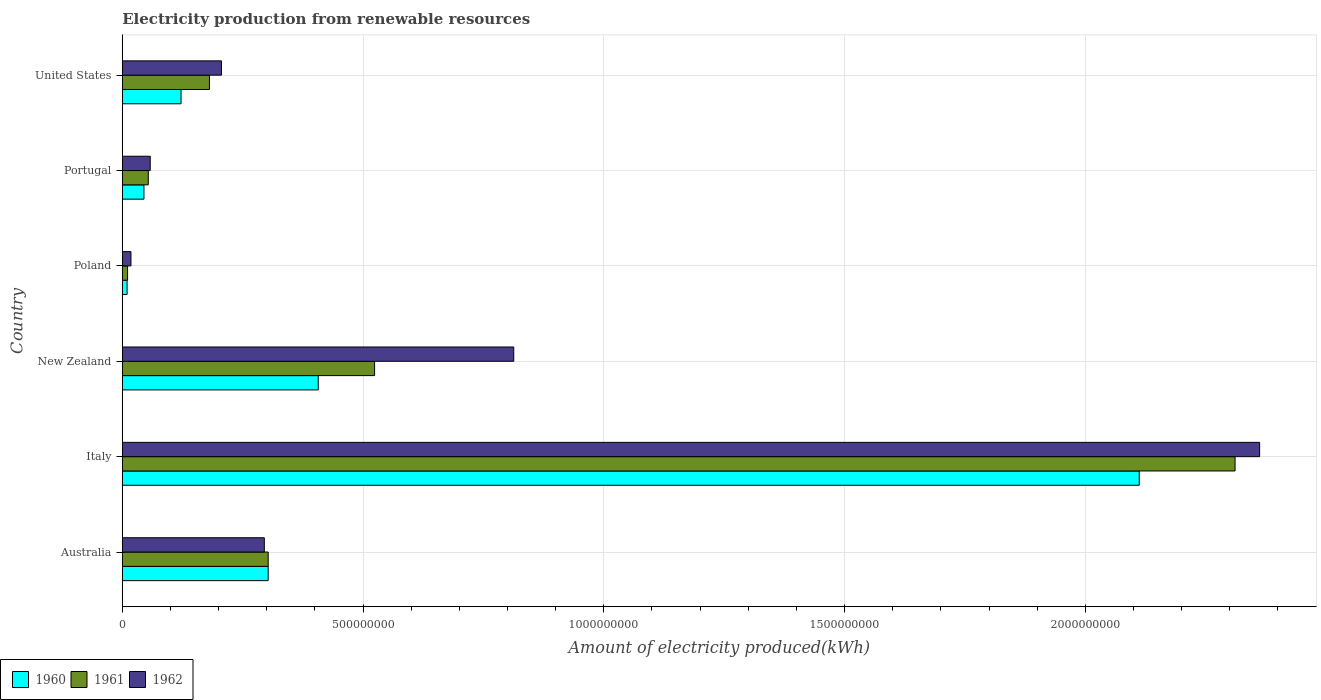Are the number of bars per tick equal to the number of legend labels?
Ensure brevity in your answer.  Yes. Are the number of bars on each tick of the Y-axis equal?
Offer a very short reply. Yes. How many bars are there on the 3rd tick from the bottom?
Provide a succinct answer. 3. Across all countries, what is the maximum amount of electricity produced in 1961?
Give a very brief answer. 2.31e+09. Across all countries, what is the minimum amount of electricity produced in 1961?
Offer a very short reply. 1.10e+07. What is the total amount of electricity produced in 1962 in the graph?
Provide a succinct answer. 3.75e+09. What is the difference between the amount of electricity produced in 1960 in New Zealand and that in Portugal?
Provide a short and direct response. 3.62e+08. What is the difference between the amount of electricity produced in 1962 in United States and the amount of electricity produced in 1960 in Portugal?
Keep it short and to the point. 1.61e+08. What is the average amount of electricity produced in 1962 per country?
Your answer should be compact. 6.25e+08. What is the difference between the amount of electricity produced in 1960 and amount of electricity produced in 1961 in Portugal?
Offer a terse response. -9.00e+06. In how many countries, is the amount of electricity produced in 1960 greater than 400000000 kWh?
Ensure brevity in your answer.  2. What is the ratio of the amount of electricity produced in 1962 in Italy to that in New Zealand?
Offer a very short reply. 2.91. Is the difference between the amount of electricity produced in 1960 in Australia and New Zealand greater than the difference between the amount of electricity produced in 1961 in Australia and New Zealand?
Offer a terse response. Yes. What is the difference between the highest and the second highest amount of electricity produced in 1961?
Give a very brief answer. 1.79e+09. What is the difference between the highest and the lowest amount of electricity produced in 1962?
Provide a succinct answer. 2.34e+09. What does the 3rd bar from the top in Portugal represents?
Provide a succinct answer. 1960. Are the values on the major ticks of X-axis written in scientific E-notation?
Provide a short and direct response. No. Does the graph contain any zero values?
Give a very brief answer. No. Where does the legend appear in the graph?
Your response must be concise. Bottom left. How many legend labels are there?
Your response must be concise. 3. What is the title of the graph?
Keep it short and to the point. Electricity production from renewable resources. Does "2001" appear as one of the legend labels in the graph?
Offer a very short reply. No. What is the label or title of the X-axis?
Ensure brevity in your answer.  Amount of electricity produced(kWh). What is the label or title of the Y-axis?
Ensure brevity in your answer.  Country. What is the Amount of electricity produced(kWh) of 1960 in Australia?
Ensure brevity in your answer.  3.03e+08. What is the Amount of electricity produced(kWh) in 1961 in Australia?
Ensure brevity in your answer.  3.03e+08. What is the Amount of electricity produced(kWh) of 1962 in Australia?
Make the answer very short. 2.95e+08. What is the Amount of electricity produced(kWh) of 1960 in Italy?
Your response must be concise. 2.11e+09. What is the Amount of electricity produced(kWh) in 1961 in Italy?
Ensure brevity in your answer.  2.31e+09. What is the Amount of electricity produced(kWh) in 1962 in Italy?
Your answer should be very brief. 2.36e+09. What is the Amount of electricity produced(kWh) of 1960 in New Zealand?
Offer a terse response. 4.07e+08. What is the Amount of electricity produced(kWh) in 1961 in New Zealand?
Your answer should be very brief. 5.24e+08. What is the Amount of electricity produced(kWh) in 1962 in New Zealand?
Make the answer very short. 8.13e+08. What is the Amount of electricity produced(kWh) in 1960 in Poland?
Provide a short and direct response. 1.00e+07. What is the Amount of electricity produced(kWh) of 1961 in Poland?
Make the answer very short. 1.10e+07. What is the Amount of electricity produced(kWh) in 1962 in Poland?
Provide a short and direct response. 1.80e+07. What is the Amount of electricity produced(kWh) of 1960 in Portugal?
Your response must be concise. 4.50e+07. What is the Amount of electricity produced(kWh) of 1961 in Portugal?
Ensure brevity in your answer.  5.40e+07. What is the Amount of electricity produced(kWh) in 1962 in Portugal?
Make the answer very short. 5.80e+07. What is the Amount of electricity produced(kWh) in 1960 in United States?
Offer a terse response. 1.22e+08. What is the Amount of electricity produced(kWh) of 1961 in United States?
Give a very brief answer. 1.81e+08. What is the Amount of electricity produced(kWh) in 1962 in United States?
Make the answer very short. 2.06e+08. Across all countries, what is the maximum Amount of electricity produced(kWh) of 1960?
Keep it short and to the point. 2.11e+09. Across all countries, what is the maximum Amount of electricity produced(kWh) of 1961?
Your answer should be very brief. 2.31e+09. Across all countries, what is the maximum Amount of electricity produced(kWh) of 1962?
Give a very brief answer. 2.36e+09. Across all countries, what is the minimum Amount of electricity produced(kWh) of 1961?
Give a very brief answer. 1.10e+07. Across all countries, what is the minimum Amount of electricity produced(kWh) in 1962?
Offer a terse response. 1.80e+07. What is the total Amount of electricity produced(kWh) in 1960 in the graph?
Offer a very short reply. 3.00e+09. What is the total Amount of electricity produced(kWh) in 1961 in the graph?
Your answer should be very brief. 3.38e+09. What is the total Amount of electricity produced(kWh) of 1962 in the graph?
Give a very brief answer. 3.75e+09. What is the difference between the Amount of electricity produced(kWh) of 1960 in Australia and that in Italy?
Your answer should be compact. -1.81e+09. What is the difference between the Amount of electricity produced(kWh) in 1961 in Australia and that in Italy?
Provide a short and direct response. -2.01e+09. What is the difference between the Amount of electricity produced(kWh) in 1962 in Australia and that in Italy?
Make the answer very short. -2.07e+09. What is the difference between the Amount of electricity produced(kWh) of 1960 in Australia and that in New Zealand?
Provide a succinct answer. -1.04e+08. What is the difference between the Amount of electricity produced(kWh) in 1961 in Australia and that in New Zealand?
Make the answer very short. -2.21e+08. What is the difference between the Amount of electricity produced(kWh) in 1962 in Australia and that in New Zealand?
Offer a very short reply. -5.18e+08. What is the difference between the Amount of electricity produced(kWh) in 1960 in Australia and that in Poland?
Give a very brief answer. 2.93e+08. What is the difference between the Amount of electricity produced(kWh) in 1961 in Australia and that in Poland?
Make the answer very short. 2.92e+08. What is the difference between the Amount of electricity produced(kWh) of 1962 in Australia and that in Poland?
Your response must be concise. 2.77e+08. What is the difference between the Amount of electricity produced(kWh) in 1960 in Australia and that in Portugal?
Your response must be concise. 2.58e+08. What is the difference between the Amount of electricity produced(kWh) of 1961 in Australia and that in Portugal?
Keep it short and to the point. 2.49e+08. What is the difference between the Amount of electricity produced(kWh) in 1962 in Australia and that in Portugal?
Offer a terse response. 2.37e+08. What is the difference between the Amount of electricity produced(kWh) of 1960 in Australia and that in United States?
Keep it short and to the point. 1.81e+08. What is the difference between the Amount of electricity produced(kWh) of 1961 in Australia and that in United States?
Give a very brief answer. 1.22e+08. What is the difference between the Amount of electricity produced(kWh) of 1962 in Australia and that in United States?
Offer a very short reply. 8.90e+07. What is the difference between the Amount of electricity produced(kWh) of 1960 in Italy and that in New Zealand?
Provide a succinct answer. 1.70e+09. What is the difference between the Amount of electricity produced(kWh) in 1961 in Italy and that in New Zealand?
Provide a short and direct response. 1.79e+09. What is the difference between the Amount of electricity produced(kWh) of 1962 in Italy and that in New Zealand?
Provide a succinct answer. 1.55e+09. What is the difference between the Amount of electricity produced(kWh) of 1960 in Italy and that in Poland?
Provide a succinct answer. 2.10e+09. What is the difference between the Amount of electricity produced(kWh) of 1961 in Italy and that in Poland?
Your answer should be compact. 2.30e+09. What is the difference between the Amount of electricity produced(kWh) of 1962 in Italy and that in Poland?
Your answer should be very brief. 2.34e+09. What is the difference between the Amount of electricity produced(kWh) of 1960 in Italy and that in Portugal?
Your response must be concise. 2.07e+09. What is the difference between the Amount of electricity produced(kWh) of 1961 in Italy and that in Portugal?
Give a very brief answer. 2.26e+09. What is the difference between the Amount of electricity produced(kWh) of 1962 in Italy and that in Portugal?
Offer a terse response. 2.30e+09. What is the difference between the Amount of electricity produced(kWh) in 1960 in Italy and that in United States?
Your answer should be very brief. 1.99e+09. What is the difference between the Amount of electricity produced(kWh) of 1961 in Italy and that in United States?
Your answer should be compact. 2.13e+09. What is the difference between the Amount of electricity produced(kWh) of 1962 in Italy and that in United States?
Your answer should be compact. 2.16e+09. What is the difference between the Amount of electricity produced(kWh) in 1960 in New Zealand and that in Poland?
Keep it short and to the point. 3.97e+08. What is the difference between the Amount of electricity produced(kWh) of 1961 in New Zealand and that in Poland?
Provide a succinct answer. 5.13e+08. What is the difference between the Amount of electricity produced(kWh) of 1962 in New Zealand and that in Poland?
Make the answer very short. 7.95e+08. What is the difference between the Amount of electricity produced(kWh) of 1960 in New Zealand and that in Portugal?
Offer a terse response. 3.62e+08. What is the difference between the Amount of electricity produced(kWh) of 1961 in New Zealand and that in Portugal?
Provide a succinct answer. 4.70e+08. What is the difference between the Amount of electricity produced(kWh) of 1962 in New Zealand and that in Portugal?
Provide a succinct answer. 7.55e+08. What is the difference between the Amount of electricity produced(kWh) of 1960 in New Zealand and that in United States?
Provide a succinct answer. 2.85e+08. What is the difference between the Amount of electricity produced(kWh) in 1961 in New Zealand and that in United States?
Your answer should be compact. 3.43e+08. What is the difference between the Amount of electricity produced(kWh) in 1962 in New Zealand and that in United States?
Your answer should be compact. 6.07e+08. What is the difference between the Amount of electricity produced(kWh) of 1960 in Poland and that in Portugal?
Give a very brief answer. -3.50e+07. What is the difference between the Amount of electricity produced(kWh) of 1961 in Poland and that in Portugal?
Offer a terse response. -4.30e+07. What is the difference between the Amount of electricity produced(kWh) in 1962 in Poland and that in Portugal?
Provide a short and direct response. -4.00e+07. What is the difference between the Amount of electricity produced(kWh) in 1960 in Poland and that in United States?
Offer a terse response. -1.12e+08. What is the difference between the Amount of electricity produced(kWh) in 1961 in Poland and that in United States?
Keep it short and to the point. -1.70e+08. What is the difference between the Amount of electricity produced(kWh) in 1962 in Poland and that in United States?
Provide a succinct answer. -1.88e+08. What is the difference between the Amount of electricity produced(kWh) in 1960 in Portugal and that in United States?
Provide a succinct answer. -7.70e+07. What is the difference between the Amount of electricity produced(kWh) of 1961 in Portugal and that in United States?
Provide a succinct answer. -1.27e+08. What is the difference between the Amount of electricity produced(kWh) in 1962 in Portugal and that in United States?
Offer a very short reply. -1.48e+08. What is the difference between the Amount of electricity produced(kWh) of 1960 in Australia and the Amount of electricity produced(kWh) of 1961 in Italy?
Your answer should be compact. -2.01e+09. What is the difference between the Amount of electricity produced(kWh) in 1960 in Australia and the Amount of electricity produced(kWh) in 1962 in Italy?
Offer a very short reply. -2.06e+09. What is the difference between the Amount of electricity produced(kWh) of 1961 in Australia and the Amount of electricity produced(kWh) of 1962 in Italy?
Ensure brevity in your answer.  -2.06e+09. What is the difference between the Amount of electricity produced(kWh) of 1960 in Australia and the Amount of electricity produced(kWh) of 1961 in New Zealand?
Provide a short and direct response. -2.21e+08. What is the difference between the Amount of electricity produced(kWh) in 1960 in Australia and the Amount of electricity produced(kWh) in 1962 in New Zealand?
Provide a succinct answer. -5.10e+08. What is the difference between the Amount of electricity produced(kWh) of 1961 in Australia and the Amount of electricity produced(kWh) of 1962 in New Zealand?
Offer a very short reply. -5.10e+08. What is the difference between the Amount of electricity produced(kWh) of 1960 in Australia and the Amount of electricity produced(kWh) of 1961 in Poland?
Provide a short and direct response. 2.92e+08. What is the difference between the Amount of electricity produced(kWh) in 1960 in Australia and the Amount of electricity produced(kWh) in 1962 in Poland?
Your answer should be very brief. 2.85e+08. What is the difference between the Amount of electricity produced(kWh) in 1961 in Australia and the Amount of electricity produced(kWh) in 1962 in Poland?
Provide a short and direct response. 2.85e+08. What is the difference between the Amount of electricity produced(kWh) in 1960 in Australia and the Amount of electricity produced(kWh) in 1961 in Portugal?
Give a very brief answer. 2.49e+08. What is the difference between the Amount of electricity produced(kWh) in 1960 in Australia and the Amount of electricity produced(kWh) in 1962 in Portugal?
Provide a short and direct response. 2.45e+08. What is the difference between the Amount of electricity produced(kWh) in 1961 in Australia and the Amount of electricity produced(kWh) in 1962 in Portugal?
Your response must be concise. 2.45e+08. What is the difference between the Amount of electricity produced(kWh) of 1960 in Australia and the Amount of electricity produced(kWh) of 1961 in United States?
Give a very brief answer. 1.22e+08. What is the difference between the Amount of electricity produced(kWh) in 1960 in Australia and the Amount of electricity produced(kWh) in 1962 in United States?
Provide a short and direct response. 9.70e+07. What is the difference between the Amount of electricity produced(kWh) in 1961 in Australia and the Amount of electricity produced(kWh) in 1962 in United States?
Your answer should be very brief. 9.70e+07. What is the difference between the Amount of electricity produced(kWh) in 1960 in Italy and the Amount of electricity produced(kWh) in 1961 in New Zealand?
Provide a succinct answer. 1.59e+09. What is the difference between the Amount of electricity produced(kWh) in 1960 in Italy and the Amount of electricity produced(kWh) in 1962 in New Zealand?
Offer a terse response. 1.30e+09. What is the difference between the Amount of electricity produced(kWh) in 1961 in Italy and the Amount of electricity produced(kWh) in 1962 in New Zealand?
Offer a very short reply. 1.50e+09. What is the difference between the Amount of electricity produced(kWh) in 1960 in Italy and the Amount of electricity produced(kWh) in 1961 in Poland?
Give a very brief answer. 2.10e+09. What is the difference between the Amount of electricity produced(kWh) in 1960 in Italy and the Amount of electricity produced(kWh) in 1962 in Poland?
Make the answer very short. 2.09e+09. What is the difference between the Amount of electricity produced(kWh) in 1961 in Italy and the Amount of electricity produced(kWh) in 1962 in Poland?
Keep it short and to the point. 2.29e+09. What is the difference between the Amount of electricity produced(kWh) of 1960 in Italy and the Amount of electricity produced(kWh) of 1961 in Portugal?
Keep it short and to the point. 2.06e+09. What is the difference between the Amount of electricity produced(kWh) in 1960 in Italy and the Amount of electricity produced(kWh) in 1962 in Portugal?
Keep it short and to the point. 2.05e+09. What is the difference between the Amount of electricity produced(kWh) of 1961 in Italy and the Amount of electricity produced(kWh) of 1962 in Portugal?
Make the answer very short. 2.25e+09. What is the difference between the Amount of electricity produced(kWh) of 1960 in Italy and the Amount of electricity produced(kWh) of 1961 in United States?
Your answer should be compact. 1.93e+09. What is the difference between the Amount of electricity produced(kWh) in 1960 in Italy and the Amount of electricity produced(kWh) in 1962 in United States?
Keep it short and to the point. 1.91e+09. What is the difference between the Amount of electricity produced(kWh) in 1961 in Italy and the Amount of electricity produced(kWh) in 1962 in United States?
Offer a terse response. 2.10e+09. What is the difference between the Amount of electricity produced(kWh) in 1960 in New Zealand and the Amount of electricity produced(kWh) in 1961 in Poland?
Offer a terse response. 3.96e+08. What is the difference between the Amount of electricity produced(kWh) of 1960 in New Zealand and the Amount of electricity produced(kWh) of 1962 in Poland?
Offer a terse response. 3.89e+08. What is the difference between the Amount of electricity produced(kWh) of 1961 in New Zealand and the Amount of electricity produced(kWh) of 1962 in Poland?
Your answer should be compact. 5.06e+08. What is the difference between the Amount of electricity produced(kWh) of 1960 in New Zealand and the Amount of electricity produced(kWh) of 1961 in Portugal?
Keep it short and to the point. 3.53e+08. What is the difference between the Amount of electricity produced(kWh) in 1960 in New Zealand and the Amount of electricity produced(kWh) in 1962 in Portugal?
Make the answer very short. 3.49e+08. What is the difference between the Amount of electricity produced(kWh) in 1961 in New Zealand and the Amount of electricity produced(kWh) in 1962 in Portugal?
Offer a terse response. 4.66e+08. What is the difference between the Amount of electricity produced(kWh) of 1960 in New Zealand and the Amount of electricity produced(kWh) of 1961 in United States?
Make the answer very short. 2.26e+08. What is the difference between the Amount of electricity produced(kWh) of 1960 in New Zealand and the Amount of electricity produced(kWh) of 1962 in United States?
Provide a short and direct response. 2.01e+08. What is the difference between the Amount of electricity produced(kWh) of 1961 in New Zealand and the Amount of electricity produced(kWh) of 1962 in United States?
Keep it short and to the point. 3.18e+08. What is the difference between the Amount of electricity produced(kWh) in 1960 in Poland and the Amount of electricity produced(kWh) in 1961 in Portugal?
Keep it short and to the point. -4.40e+07. What is the difference between the Amount of electricity produced(kWh) in 1960 in Poland and the Amount of electricity produced(kWh) in 1962 in Portugal?
Offer a terse response. -4.80e+07. What is the difference between the Amount of electricity produced(kWh) of 1961 in Poland and the Amount of electricity produced(kWh) of 1962 in Portugal?
Your answer should be compact. -4.70e+07. What is the difference between the Amount of electricity produced(kWh) in 1960 in Poland and the Amount of electricity produced(kWh) in 1961 in United States?
Your answer should be very brief. -1.71e+08. What is the difference between the Amount of electricity produced(kWh) of 1960 in Poland and the Amount of electricity produced(kWh) of 1962 in United States?
Offer a terse response. -1.96e+08. What is the difference between the Amount of electricity produced(kWh) in 1961 in Poland and the Amount of electricity produced(kWh) in 1962 in United States?
Offer a very short reply. -1.95e+08. What is the difference between the Amount of electricity produced(kWh) of 1960 in Portugal and the Amount of electricity produced(kWh) of 1961 in United States?
Offer a very short reply. -1.36e+08. What is the difference between the Amount of electricity produced(kWh) in 1960 in Portugal and the Amount of electricity produced(kWh) in 1962 in United States?
Provide a succinct answer. -1.61e+08. What is the difference between the Amount of electricity produced(kWh) in 1961 in Portugal and the Amount of electricity produced(kWh) in 1962 in United States?
Provide a short and direct response. -1.52e+08. What is the average Amount of electricity produced(kWh) of 1960 per country?
Make the answer very short. 5.00e+08. What is the average Amount of electricity produced(kWh) in 1961 per country?
Offer a terse response. 5.64e+08. What is the average Amount of electricity produced(kWh) in 1962 per country?
Offer a very short reply. 6.25e+08. What is the difference between the Amount of electricity produced(kWh) in 1960 and Amount of electricity produced(kWh) in 1962 in Australia?
Ensure brevity in your answer.  8.00e+06. What is the difference between the Amount of electricity produced(kWh) of 1960 and Amount of electricity produced(kWh) of 1961 in Italy?
Ensure brevity in your answer.  -1.99e+08. What is the difference between the Amount of electricity produced(kWh) of 1960 and Amount of electricity produced(kWh) of 1962 in Italy?
Your answer should be very brief. -2.50e+08. What is the difference between the Amount of electricity produced(kWh) in 1961 and Amount of electricity produced(kWh) in 1962 in Italy?
Your answer should be compact. -5.10e+07. What is the difference between the Amount of electricity produced(kWh) in 1960 and Amount of electricity produced(kWh) in 1961 in New Zealand?
Offer a terse response. -1.17e+08. What is the difference between the Amount of electricity produced(kWh) of 1960 and Amount of electricity produced(kWh) of 1962 in New Zealand?
Your answer should be compact. -4.06e+08. What is the difference between the Amount of electricity produced(kWh) of 1961 and Amount of electricity produced(kWh) of 1962 in New Zealand?
Your answer should be compact. -2.89e+08. What is the difference between the Amount of electricity produced(kWh) of 1960 and Amount of electricity produced(kWh) of 1962 in Poland?
Ensure brevity in your answer.  -8.00e+06. What is the difference between the Amount of electricity produced(kWh) of 1961 and Amount of electricity produced(kWh) of 1962 in Poland?
Your answer should be compact. -7.00e+06. What is the difference between the Amount of electricity produced(kWh) of 1960 and Amount of electricity produced(kWh) of 1961 in Portugal?
Your answer should be compact. -9.00e+06. What is the difference between the Amount of electricity produced(kWh) of 1960 and Amount of electricity produced(kWh) of 1962 in Portugal?
Make the answer very short. -1.30e+07. What is the difference between the Amount of electricity produced(kWh) of 1960 and Amount of electricity produced(kWh) of 1961 in United States?
Give a very brief answer. -5.90e+07. What is the difference between the Amount of electricity produced(kWh) in 1960 and Amount of electricity produced(kWh) in 1962 in United States?
Offer a terse response. -8.40e+07. What is the difference between the Amount of electricity produced(kWh) of 1961 and Amount of electricity produced(kWh) of 1962 in United States?
Provide a short and direct response. -2.50e+07. What is the ratio of the Amount of electricity produced(kWh) of 1960 in Australia to that in Italy?
Offer a terse response. 0.14. What is the ratio of the Amount of electricity produced(kWh) in 1961 in Australia to that in Italy?
Keep it short and to the point. 0.13. What is the ratio of the Amount of electricity produced(kWh) of 1962 in Australia to that in Italy?
Keep it short and to the point. 0.12. What is the ratio of the Amount of electricity produced(kWh) of 1960 in Australia to that in New Zealand?
Your answer should be very brief. 0.74. What is the ratio of the Amount of electricity produced(kWh) of 1961 in Australia to that in New Zealand?
Offer a very short reply. 0.58. What is the ratio of the Amount of electricity produced(kWh) in 1962 in Australia to that in New Zealand?
Your answer should be compact. 0.36. What is the ratio of the Amount of electricity produced(kWh) in 1960 in Australia to that in Poland?
Your answer should be very brief. 30.3. What is the ratio of the Amount of electricity produced(kWh) in 1961 in Australia to that in Poland?
Offer a very short reply. 27.55. What is the ratio of the Amount of electricity produced(kWh) in 1962 in Australia to that in Poland?
Offer a very short reply. 16.39. What is the ratio of the Amount of electricity produced(kWh) of 1960 in Australia to that in Portugal?
Give a very brief answer. 6.73. What is the ratio of the Amount of electricity produced(kWh) in 1961 in Australia to that in Portugal?
Offer a terse response. 5.61. What is the ratio of the Amount of electricity produced(kWh) in 1962 in Australia to that in Portugal?
Offer a terse response. 5.09. What is the ratio of the Amount of electricity produced(kWh) of 1960 in Australia to that in United States?
Ensure brevity in your answer.  2.48. What is the ratio of the Amount of electricity produced(kWh) of 1961 in Australia to that in United States?
Your response must be concise. 1.67. What is the ratio of the Amount of electricity produced(kWh) in 1962 in Australia to that in United States?
Offer a terse response. 1.43. What is the ratio of the Amount of electricity produced(kWh) in 1960 in Italy to that in New Zealand?
Give a very brief answer. 5.19. What is the ratio of the Amount of electricity produced(kWh) of 1961 in Italy to that in New Zealand?
Offer a very short reply. 4.41. What is the ratio of the Amount of electricity produced(kWh) in 1962 in Italy to that in New Zealand?
Give a very brief answer. 2.91. What is the ratio of the Amount of electricity produced(kWh) of 1960 in Italy to that in Poland?
Keep it short and to the point. 211.2. What is the ratio of the Amount of electricity produced(kWh) of 1961 in Italy to that in Poland?
Keep it short and to the point. 210.09. What is the ratio of the Amount of electricity produced(kWh) of 1962 in Italy to that in Poland?
Offer a terse response. 131.22. What is the ratio of the Amount of electricity produced(kWh) of 1960 in Italy to that in Portugal?
Your answer should be very brief. 46.93. What is the ratio of the Amount of electricity produced(kWh) of 1961 in Italy to that in Portugal?
Give a very brief answer. 42.8. What is the ratio of the Amount of electricity produced(kWh) of 1962 in Italy to that in Portugal?
Offer a very short reply. 40.72. What is the ratio of the Amount of electricity produced(kWh) in 1960 in Italy to that in United States?
Your answer should be very brief. 17.31. What is the ratio of the Amount of electricity produced(kWh) of 1961 in Italy to that in United States?
Your answer should be compact. 12.77. What is the ratio of the Amount of electricity produced(kWh) in 1962 in Italy to that in United States?
Offer a very short reply. 11.47. What is the ratio of the Amount of electricity produced(kWh) of 1960 in New Zealand to that in Poland?
Ensure brevity in your answer.  40.7. What is the ratio of the Amount of electricity produced(kWh) in 1961 in New Zealand to that in Poland?
Your answer should be compact. 47.64. What is the ratio of the Amount of electricity produced(kWh) in 1962 in New Zealand to that in Poland?
Provide a succinct answer. 45.17. What is the ratio of the Amount of electricity produced(kWh) of 1960 in New Zealand to that in Portugal?
Your answer should be very brief. 9.04. What is the ratio of the Amount of electricity produced(kWh) of 1961 in New Zealand to that in Portugal?
Ensure brevity in your answer.  9.7. What is the ratio of the Amount of electricity produced(kWh) in 1962 in New Zealand to that in Portugal?
Provide a succinct answer. 14.02. What is the ratio of the Amount of electricity produced(kWh) in 1960 in New Zealand to that in United States?
Provide a succinct answer. 3.34. What is the ratio of the Amount of electricity produced(kWh) in 1961 in New Zealand to that in United States?
Provide a succinct answer. 2.9. What is the ratio of the Amount of electricity produced(kWh) of 1962 in New Zealand to that in United States?
Your answer should be very brief. 3.95. What is the ratio of the Amount of electricity produced(kWh) of 1960 in Poland to that in Portugal?
Offer a very short reply. 0.22. What is the ratio of the Amount of electricity produced(kWh) of 1961 in Poland to that in Portugal?
Ensure brevity in your answer.  0.2. What is the ratio of the Amount of electricity produced(kWh) of 1962 in Poland to that in Portugal?
Ensure brevity in your answer.  0.31. What is the ratio of the Amount of electricity produced(kWh) in 1960 in Poland to that in United States?
Offer a very short reply. 0.08. What is the ratio of the Amount of electricity produced(kWh) of 1961 in Poland to that in United States?
Provide a succinct answer. 0.06. What is the ratio of the Amount of electricity produced(kWh) in 1962 in Poland to that in United States?
Offer a terse response. 0.09. What is the ratio of the Amount of electricity produced(kWh) in 1960 in Portugal to that in United States?
Offer a very short reply. 0.37. What is the ratio of the Amount of electricity produced(kWh) in 1961 in Portugal to that in United States?
Offer a very short reply. 0.3. What is the ratio of the Amount of electricity produced(kWh) in 1962 in Portugal to that in United States?
Offer a very short reply. 0.28. What is the difference between the highest and the second highest Amount of electricity produced(kWh) of 1960?
Provide a succinct answer. 1.70e+09. What is the difference between the highest and the second highest Amount of electricity produced(kWh) in 1961?
Provide a short and direct response. 1.79e+09. What is the difference between the highest and the second highest Amount of electricity produced(kWh) in 1962?
Your answer should be compact. 1.55e+09. What is the difference between the highest and the lowest Amount of electricity produced(kWh) of 1960?
Provide a short and direct response. 2.10e+09. What is the difference between the highest and the lowest Amount of electricity produced(kWh) in 1961?
Offer a terse response. 2.30e+09. What is the difference between the highest and the lowest Amount of electricity produced(kWh) in 1962?
Make the answer very short. 2.34e+09. 